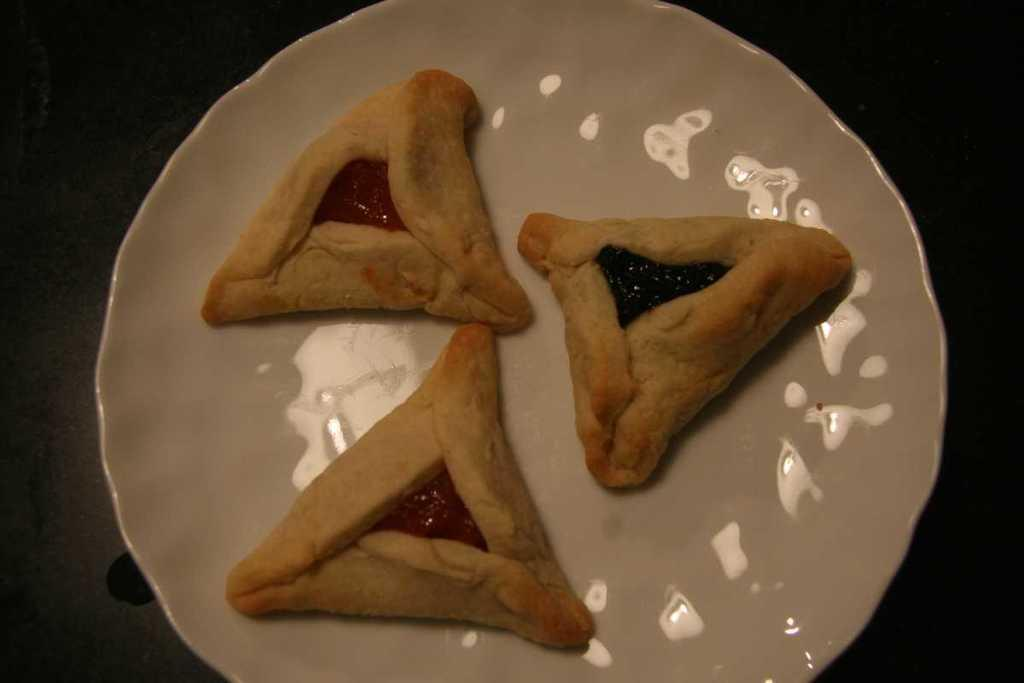What type of food can be seen in the image? The food in the image has cream, red, and green colors. How is the food presented in the image? The food is on a plate in the image. What color is the plate? The plate is white. What type of juice is being served in the cemetery in the image? There is no juice or cemetery present in the image; it features food on a white plate. 